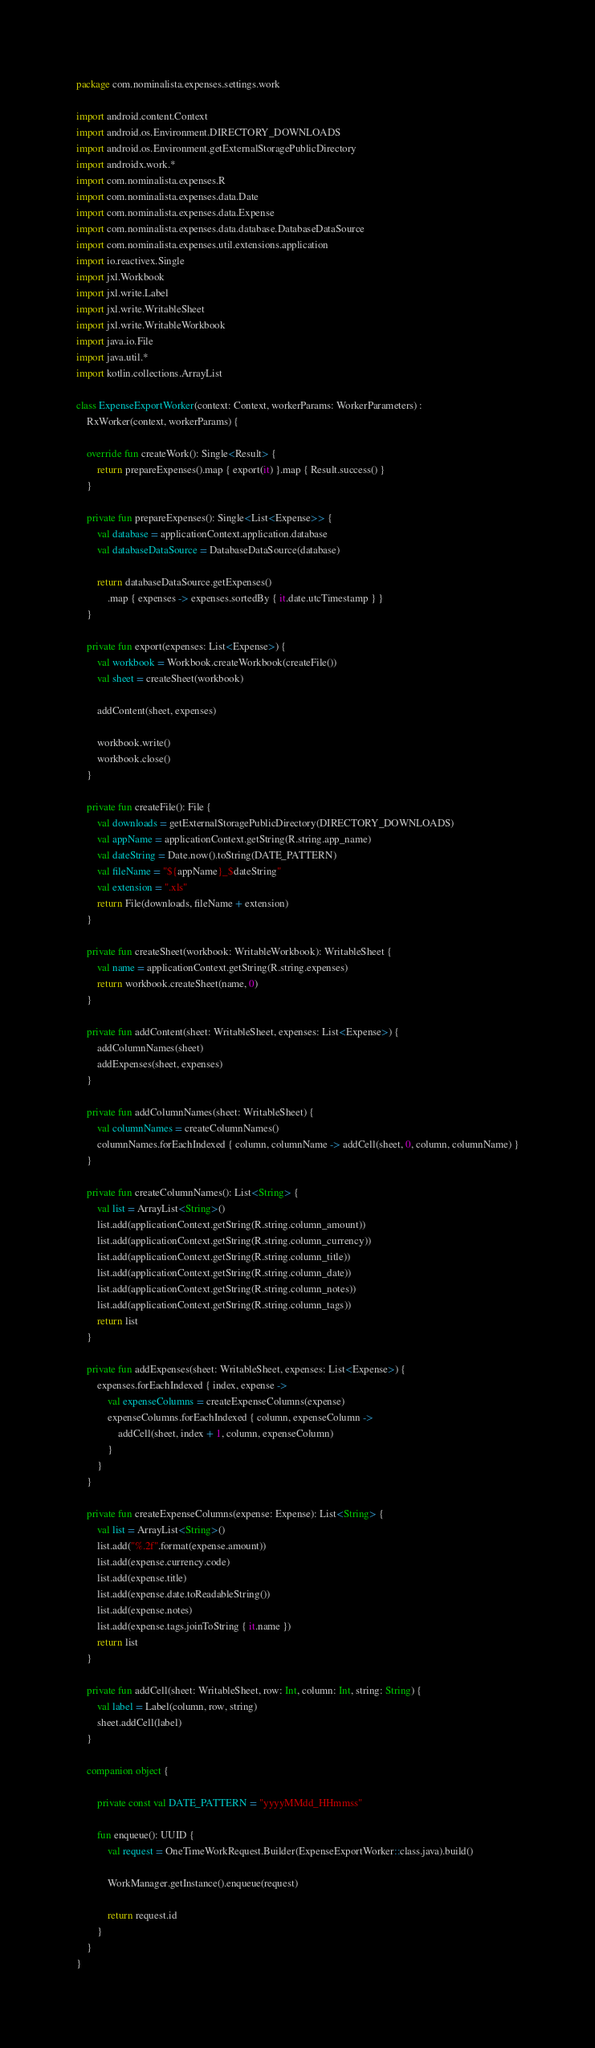Convert code to text. <code><loc_0><loc_0><loc_500><loc_500><_Kotlin_>package com.nominalista.expenses.settings.work

import android.content.Context
import android.os.Environment.DIRECTORY_DOWNLOADS
import android.os.Environment.getExternalStoragePublicDirectory
import androidx.work.*
import com.nominalista.expenses.R
import com.nominalista.expenses.data.Date
import com.nominalista.expenses.data.Expense
import com.nominalista.expenses.data.database.DatabaseDataSource
import com.nominalista.expenses.util.extensions.application
import io.reactivex.Single
import jxl.Workbook
import jxl.write.Label
import jxl.write.WritableSheet
import jxl.write.WritableWorkbook
import java.io.File
import java.util.*
import kotlin.collections.ArrayList

class ExpenseExportWorker(context: Context, workerParams: WorkerParameters) :
    RxWorker(context, workerParams) {

    override fun createWork(): Single<Result> {
        return prepareExpenses().map { export(it) }.map { Result.success() }
    }

    private fun prepareExpenses(): Single<List<Expense>> {
        val database = applicationContext.application.database
        val databaseDataSource = DatabaseDataSource(database)

        return databaseDataSource.getExpenses()
            .map { expenses -> expenses.sortedBy { it.date.utcTimestamp } }
    }

    private fun export(expenses: List<Expense>) {
        val workbook = Workbook.createWorkbook(createFile())
        val sheet = createSheet(workbook)

        addContent(sheet, expenses)

        workbook.write()
        workbook.close()
    }

    private fun createFile(): File {
        val downloads = getExternalStoragePublicDirectory(DIRECTORY_DOWNLOADS)
        val appName = applicationContext.getString(R.string.app_name)
        val dateString = Date.now().toString(DATE_PATTERN)
        val fileName = "${appName}_$dateString"
        val extension = ".xls"
        return File(downloads, fileName + extension)
    }

    private fun createSheet(workbook: WritableWorkbook): WritableSheet {
        val name = applicationContext.getString(R.string.expenses)
        return workbook.createSheet(name, 0)
    }

    private fun addContent(sheet: WritableSheet, expenses: List<Expense>) {
        addColumnNames(sheet)
        addExpenses(sheet, expenses)
    }

    private fun addColumnNames(sheet: WritableSheet) {
        val columnNames = createColumnNames()
        columnNames.forEachIndexed { column, columnName -> addCell(sheet, 0, column, columnName) }
    }

    private fun createColumnNames(): List<String> {
        val list = ArrayList<String>()
        list.add(applicationContext.getString(R.string.column_amount))
        list.add(applicationContext.getString(R.string.column_currency))
        list.add(applicationContext.getString(R.string.column_title))
        list.add(applicationContext.getString(R.string.column_date))
        list.add(applicationContext.getString(R.string.column_notes))
        list.add(applicationContext.getString(R.string.column_tags))
        return list
    }

    private fun addExpenses(sheet: WritableSheet, expenses: List<Expense>) {
        expenses.forEachIndexed { index, expense ->
            val expenseColumns = createExpenseColumns(expense)
            expenseColumns.forEachIndexed { column, expenseColumn ->
                addCell(sheet, index + 1, column, expenseColumn)
            }
        }
    }

    private fun createExpenseColumns(expense: Expense): List<String> {
        val list = ArrayList<String>()
        list.add("%.2f".format(expense.amount))
        list.add(expense.currency.code)
        list.add(expense.title)
        list.add(expense.date.toReadableString())
        list.add(expense.notes)
        list.add(expense.tags.joinToString { it.name })
        return list
    }

    private fun addCell(sheet: WritableSheet, row: Int, column: Int, string: String) {
        val label = Label(column, row, string)
        sheet.addCell(label)
    }

    companion object {

        private const val DATE_PATTERN = "yyyyMMdd_HHmmss"

        fun enqueue(): UUID {
            val request = OneTimeWorkRequest.Builder(ExpenseExportWorker::class.java).build()

            WorkManager.getInstance().enqueue(request)

            return request.id
        }
    }
}</code> 